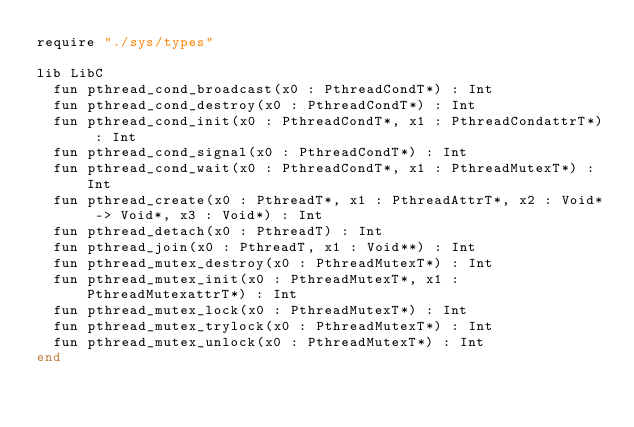Convert code to text. <code><loc_0><loc_0><loc_500><loc_500><_Crystal_>require "./sys/types"

lib LibC
  fun pthread_cond_broadcast(x0 : PthreadCondT*) : Int
  fun pthread_cond_destroy(x0 : PthreadCondT*) : Int
  fun pthread_cond_init(x0 : PthreadCondT*, x1 : PthreadCondattrT*) : Int
  fun pthread_cond_signal(x0 : PthreadCondT*) : Int
  fun pthread_cond_wait(x0 : PthreadCondT*, x1 : PthreadMutexT*) : Int
  fun pthread_create(x0 : PthreadT*, x1 : PthreadAttrT*, x2 : Void* -> Void*, x3 : Void*) : Int
  fun pthread_detach(x0 : PthreadT) : Int
  fun pthread_join(x0 : PthreadT, x1 : Void**) : Int
  fun pthread_mutex_destroy(x0 : PthreadMutexT*) : Int
  fun pthread_mutex_init(x0 : PthreadMutexT*, x1 : PthreadMutexattrT*) : Int
  fun pthread_mutex_lock(x0 : PthreadMutexT*) : Int
  fun pthread_mutex_trylock(x0 : PthreadMutexT*) : Int
  fun pthread_mutex_unlock(x0 : PthreadMutexT*) : Int
end
</code> 